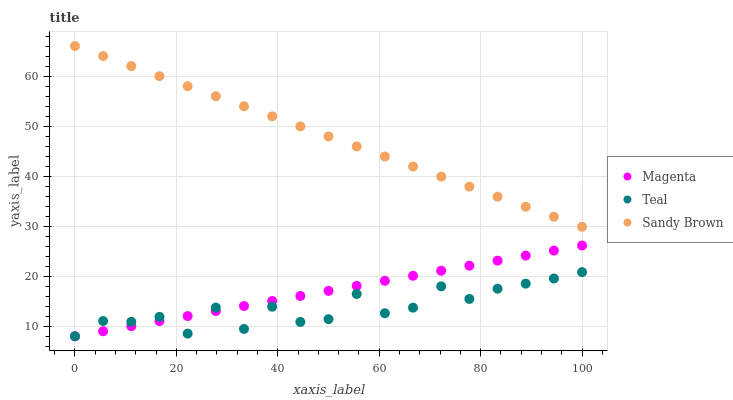Does Teal have the minimum area under the curve?
Answer yes or no. Yes. Does Sandy Brown have the maximum area under the curve?
Answer yes or no. Yes. Does Sandy Brown have the minimum area under the curve?
Answer yes or no. No. Does Teal have the maximum area under the curve?
Answer yes or no. No. Is Magenta the smoothest?
Answer yes or no. Yes. Is Teal the roughest?
Answer yes or no. Yes. Is Sandy Brown the smoothest?
Answer yes or no. No. Is Sandy Brown the roughest?
Answer yes or no. No. Does Magenta have the lowest value?
Answer yes or no. Yes. Does Sandy Brown have the lowest value?
Answer yes or no. No. Does Sandy Brown have the highest value?
Answer yes or no. Yes. Does Teal have the highest value?
Answer yes or no. No. Is Magenta less than Sandy Brown?
Answer yes or no. Yes. Is Sandy Brown greater than Teal?
Answer yes or no. Yes. Does Teal intersect Magenta?
Answer yes or no. Yes. Is Teal less than Magenta?
Answer yes or no. No. Is Teal greater than Magenta?
Answer yes or no. No. Does Magenta intersect Sandy Brown?
Answer yes or no. No. 